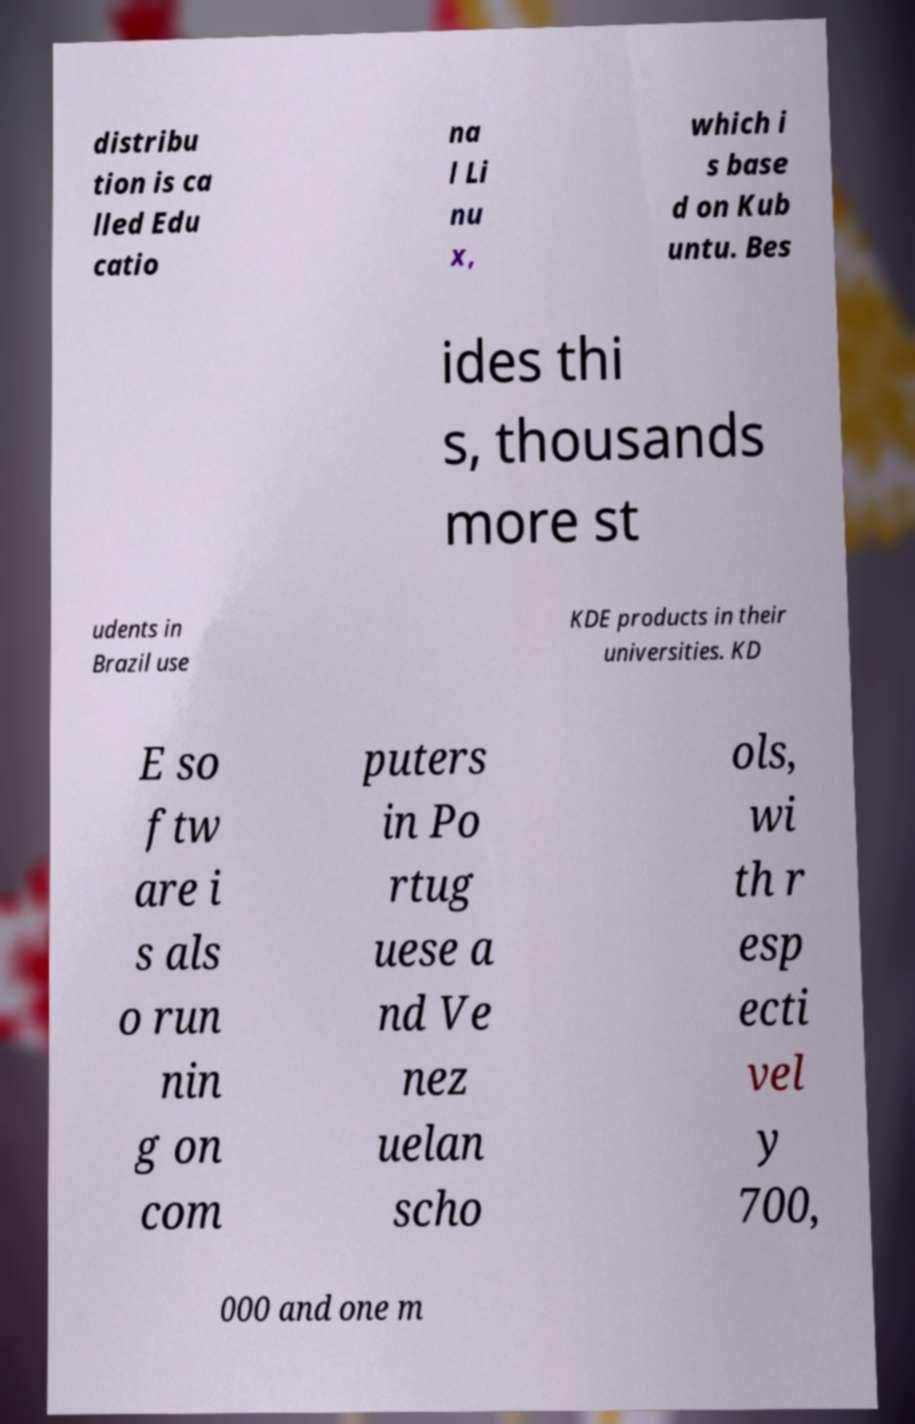Can you accurately transcribe the text from the provided image for me? distribu tion is ca lled Edu catio na l Li nu x, which i s base d on Kub untu. Bes ides thi s, thousands more st udents in Brazil use KDE products in their universities. KD E so ftw are i s als o run nin g on com puters in Po rtug uese a nd Ve nez uelan scho ols, wi th r esp ecti vel y 700, 000 and one m 